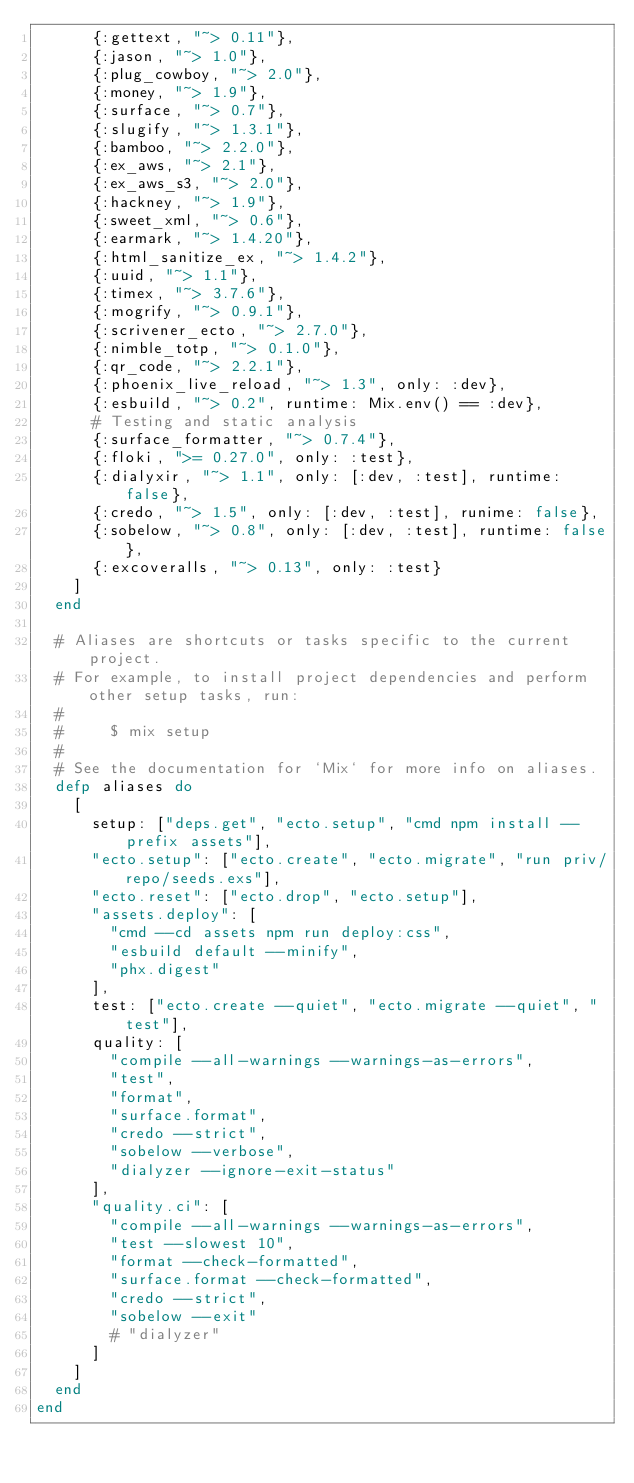Convert code to text. <code><loc_0><loc_0><loc_500><loc_500><_Elixir_>      {:gettext, "~> 0.11"},
      {:jason, "~> 1.0"},
      {:plug_cowboy, "~> 2.0"},
      {:money, "~> 1.9"},
      {:surface, "~> 0.7"},
      {:slugify, "~> 1.3.1"},
      {:bamboo, "~> 2.2.0"},
      {:ex_aws, "~> 2.1"},
      {:ex_aws_s3, "~> 2.0"},
      {:hackney, "~> 1.9"},
      {:sweet_xml, "~> 0.6"},
      {:earmark, "~> 1.4.20"},
      {:html_sanitize_ex, "~> 1.4.2"},
      {:uuid, "~> 1.1"},
      {:timex, "~> 3.7.6"},
      {:mogrify, "~> 0.9.1"},
      {:scrivener_ecto, "~> 2.7.0"},
      {:nimble_totp, "~> 0.1.0"},
      {:qr_code, "~> 2.2.1"},
      {:phoenix_live_reload, "~> 1.3", only: :dev},
      {:esbuild, "~> 0.2", runtime: Mix.env() == :dev},
      # Testing and static analysis
      {:surface_formatter, "~> 0.7.4"},
      {:floki, ">= 0.27.0", only: :test},
      {:dialyxir, "~> 1.1", only: [:dev, :test], runtime: false},
      {:credo, "~> 1.5", only: [:dev, :test], runime: false},
      {:sobelow, "~> 0.8", only: [:dev, :test], runtime: false},
      {:excoveralls, "~> 0.13", only: :test}
    ]
  end

  # Aliases are shortcuts or tasks specific to the current project.
  # For example, to install project dependencies and perform other setup tasks, run:
  #
  #     $ mix setup
  #
  # See the documentation for `Mix` for more info on aliases.
  defp aliases do
    [
      setup: ["deps.get", "ecto.setup", "cmd npm install --prefix assets"],
      "ecto.setup": ["ecto.create", "ecto.migrate", "run priv/repo/seeds.exs"],
      "ecto.reset": ["ecto.drop", "ecto.setup"],
      "assets.deploy": [
        "cmd --cd assets npm run deploy:css",
        "esbuild default --minify",
        "phx.digest"
      ],
      test: ["ecto.create --quiet", "ecto.migrate --quiet", "test"],
      quality: [
        "compile --all-warnings --warnings-as-errors",
        "test",
        "format",
        "surface.format",
        "credo --strict",
        "sobelow --verbose",
        "dialyzer --ignore-exit-status"
      ],
      "quality.ci": [
        "compile --all-warnings --warnings-as-errors",
        "test --slowest 10",
        "format --check-formatted",
        "surface.format --check-formatted",
        "credo --strict",
        "sobelow --exit"
        # "dialyzer"
      ]
    ]
  end
end
</code> 